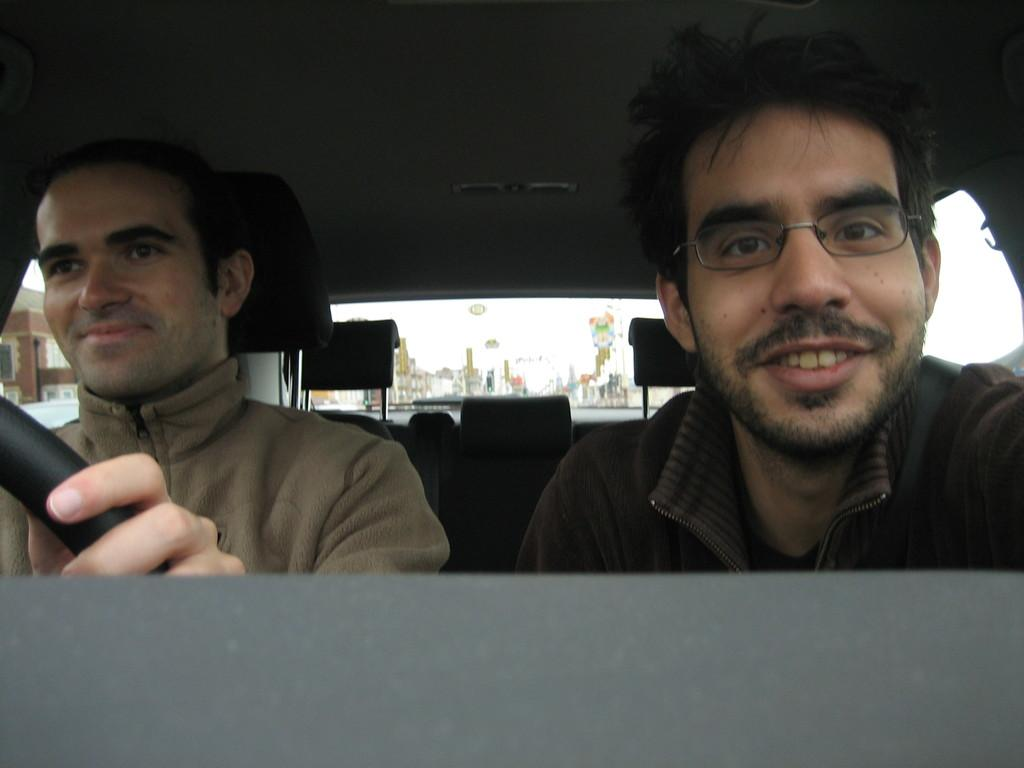Where is the image taken? The image is taken inside a car. How many people are in the image? There are two men in the image. What is the relationship between the two men? Both men are men, but their relationship is not specified in the image. What is the role of one of the men in the image? One of the men is driving the car. What type of idea is being discussed by the men in the image? There is no indication in the image that the men are discussing any ideas. Can you see a swing in the image? No, there is no swing present in the image. 